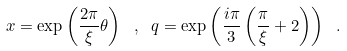Convert formula to latex. <formula><loc_0><loc_0><loc_500><loc_500>x = \exp \left ( \frac { 2 \pi } { \xi } \theta \right ) \ , \ q = \exp \left ( \frac { i \pi } { 3 } \left ( \frac { \pi } { \xi } + 2 \right ) \right ) \ .</formula> 